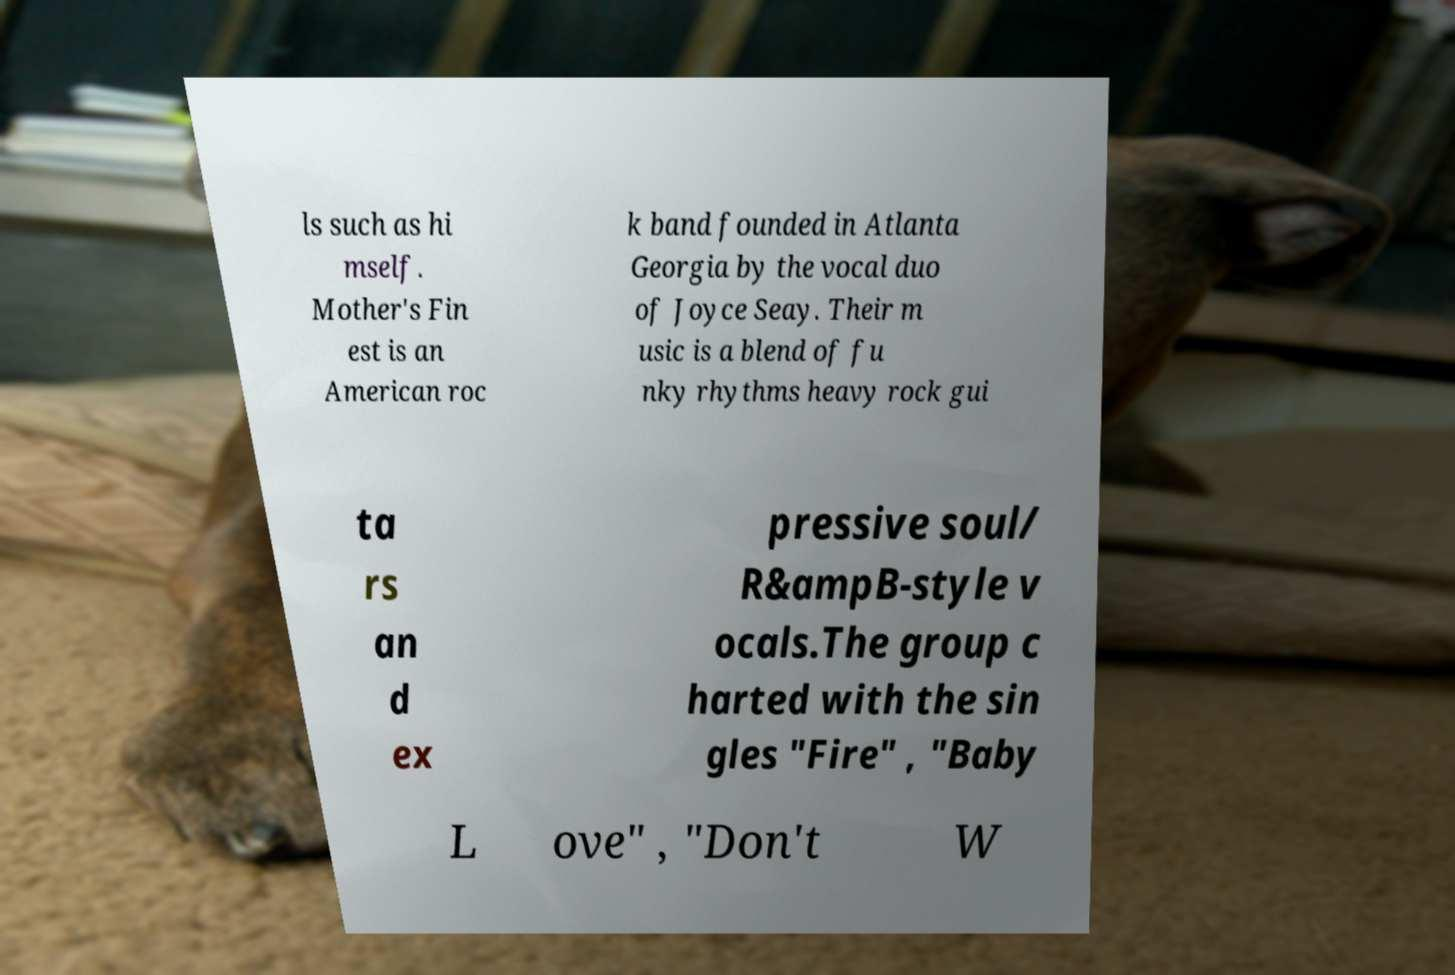Please read and relay the text visible in this image. What does it say? ls such as hi mself. Mother's Fin est is an American roc k band founded in Atlanta Georgia by the vocal duo of Joyce Seay. Their m usic is a blend of fu nky rhythms heavy rock gui ta rs an d ex pressive soul/ R&ampB-style v ocals.The group c harted with the sin gles "Fire" , "Baby L ove" , "Don't W 